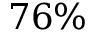Convert formula to latex. <formula><loc_0><loc_0><loc_500><loc_500>7 6 \%</formula> 